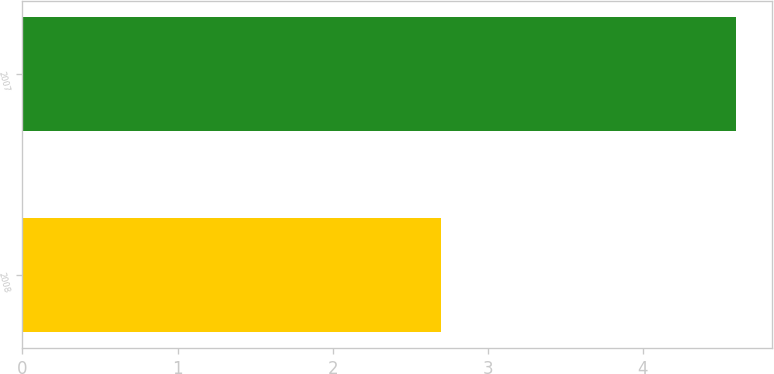Convert chart to OTSL. <chart><loc_0><loc_0><loc_500><loc_500><bar_chart><fcel>2008<fcel>2007<nl><fcel>2.7<fcel>4.6<nl></chart> 